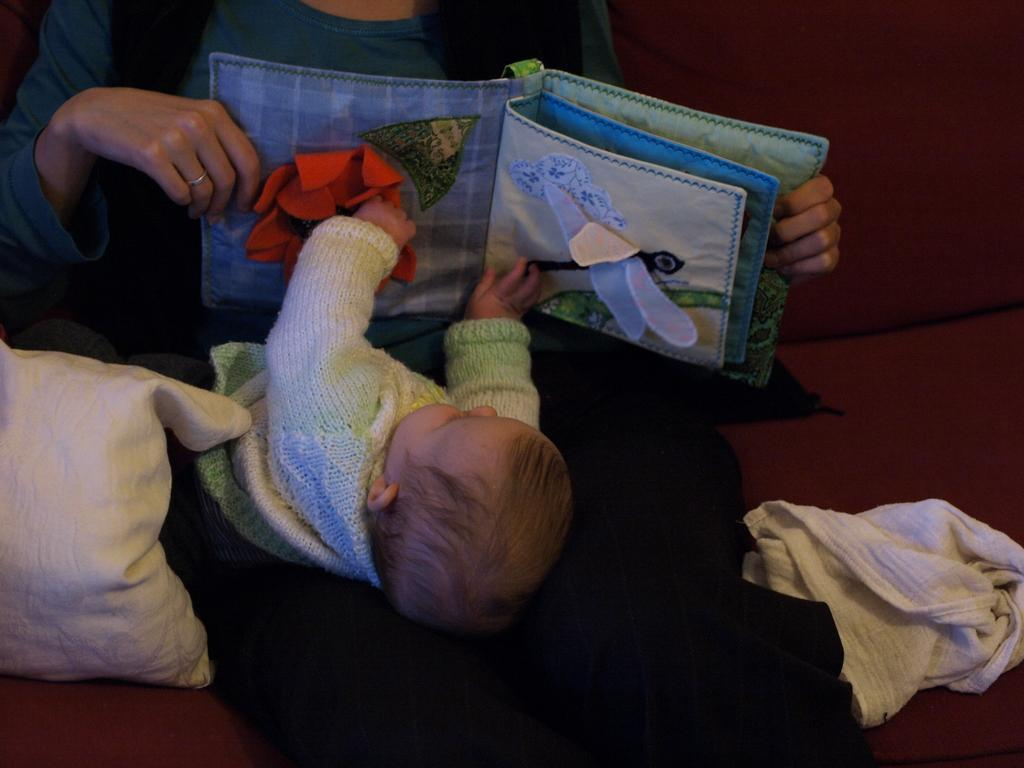What is the person in the image holding? The person is holding a toy in the image. Who else is present in the image? There is a kid in the image. What type of material can be seen in the image? There is cloth visible in the image. What object can be used for support or comfort in the image? There is a pillow in the image. What is the name of the mitten in the image? There is no mitten present in the image. What can be observed in the aftermath of the event in the image? There is no event or aftermath mentioned in the provided facts, so we cannot answer this question. 